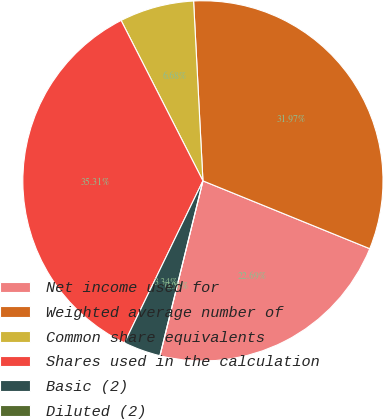Convert chart. <chart><loc_0><loc_0><loc_500><loc_500><pie_chart><fcel>Net income used for<fcel>Weighted average number of<fcel>Common share equivalents<fcel>Shares used in the calculation<fcel>Basic (2)<fcel>Diluted (2)<nl><fcel>22.69%<fcel>31.97%<fcel>6.68%<fcel>35.31%<fcel>3.34%<fcel>0.0%<nl></chart> 